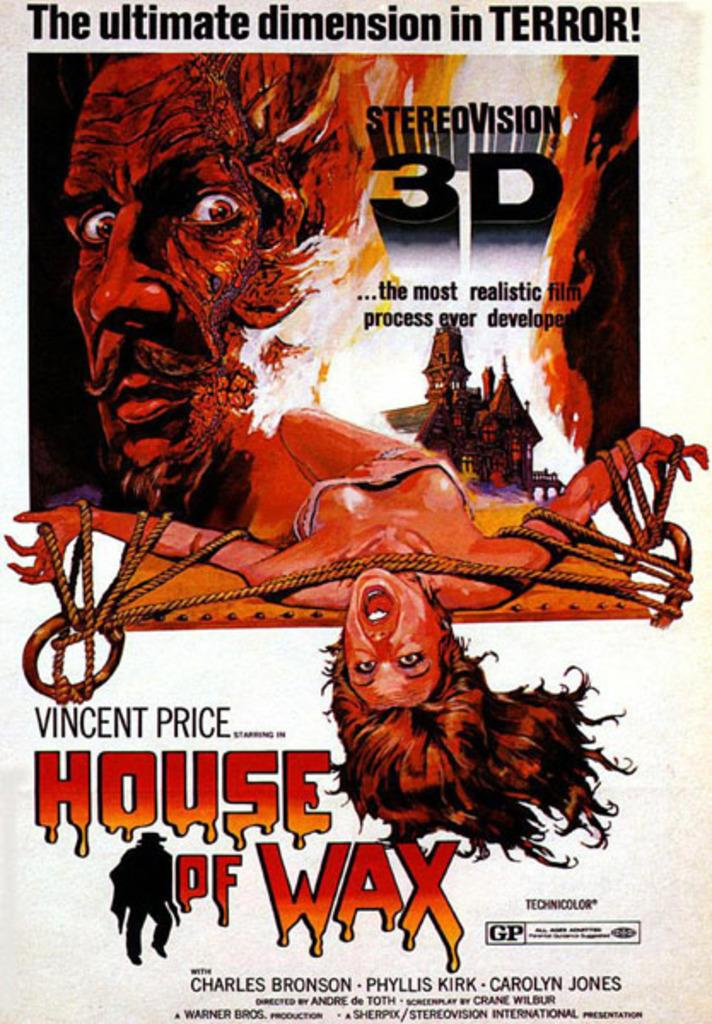<image>
Relay a brief, clear account of the picture shown. The House of Wax movie is advertised in 3D. 